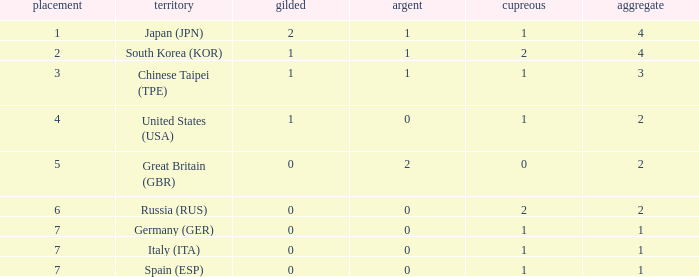What is the rank of the country with more than 2 medals, and 2 gold medals? 1.0. 